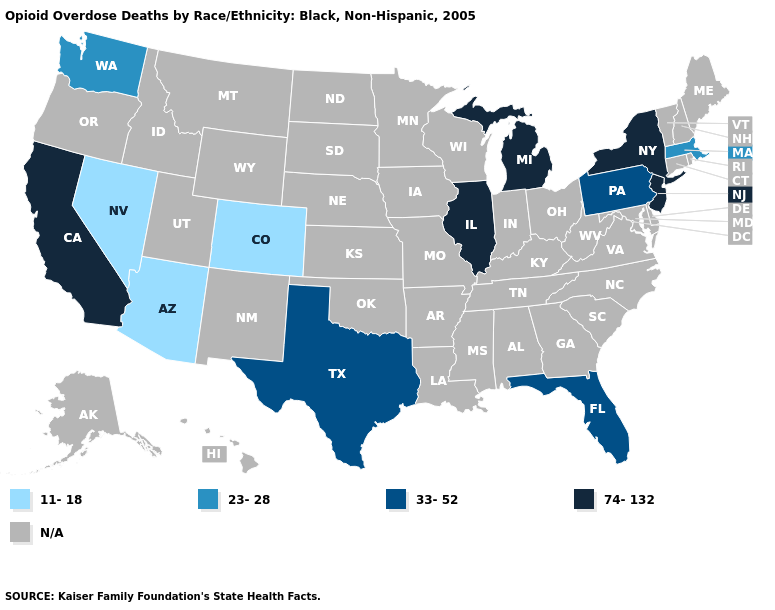Which states hav the highest value in the Northeast?
Write a very short answer. New Jersey, New York. Name the states that have a value in the range 23-28?
Keep it brief. Massachusetts, Washington. Which states have the lowest value in the MidWest?
Quick response, please. Illinois, Michigan. Name the states that have a value in the range 33-52?
Answer briefly. Florida, Pennsylvania, Texas. What is the value of Texas?
Answer briefly. 33-52. What is the value of Arizona?
Write a very short answer. 11-18. Name the states that have a value in the range N/A?
Concise answer only. Alabama, Alaska, Arkansas, Connecticut, Delaware, Georgia, Hawaii, Idaho, Indiana, Iowa, Kansas, Kentucky, Louisiana, Maine, Maryland, Minnesota, Mississippi, Missouri, Montana, Nebraska, New Hampshire, New Mexico, North Carolina, North Dakota, Ohio, Oklahoma, Oregon, Rhode Island, South Carolina, South Dakota, Tennessee, Utah, Vermont, Virginia, West Virginia, Wisconsin, Wyoming. Is the legend a continuous bar?
Write a very short answer. No. What is the value of New Jersey?
Give a very brief answer. 74-132. Name the states that have a value in the range 23-28?
Be succinct. Massachusetts, Washington. Does the first symbol in the legend represent the smallest category?
Be succinct. Yes. Which states have the lowest value in the USA?
Short answer required. Arizona, Colorado, Nevada. What is the lowest value in the South?
Quick response, please. 33-52. Name the states that have a value in the range 11-18?
Write a very short answer. Arizona, Colorado, Nevada. 